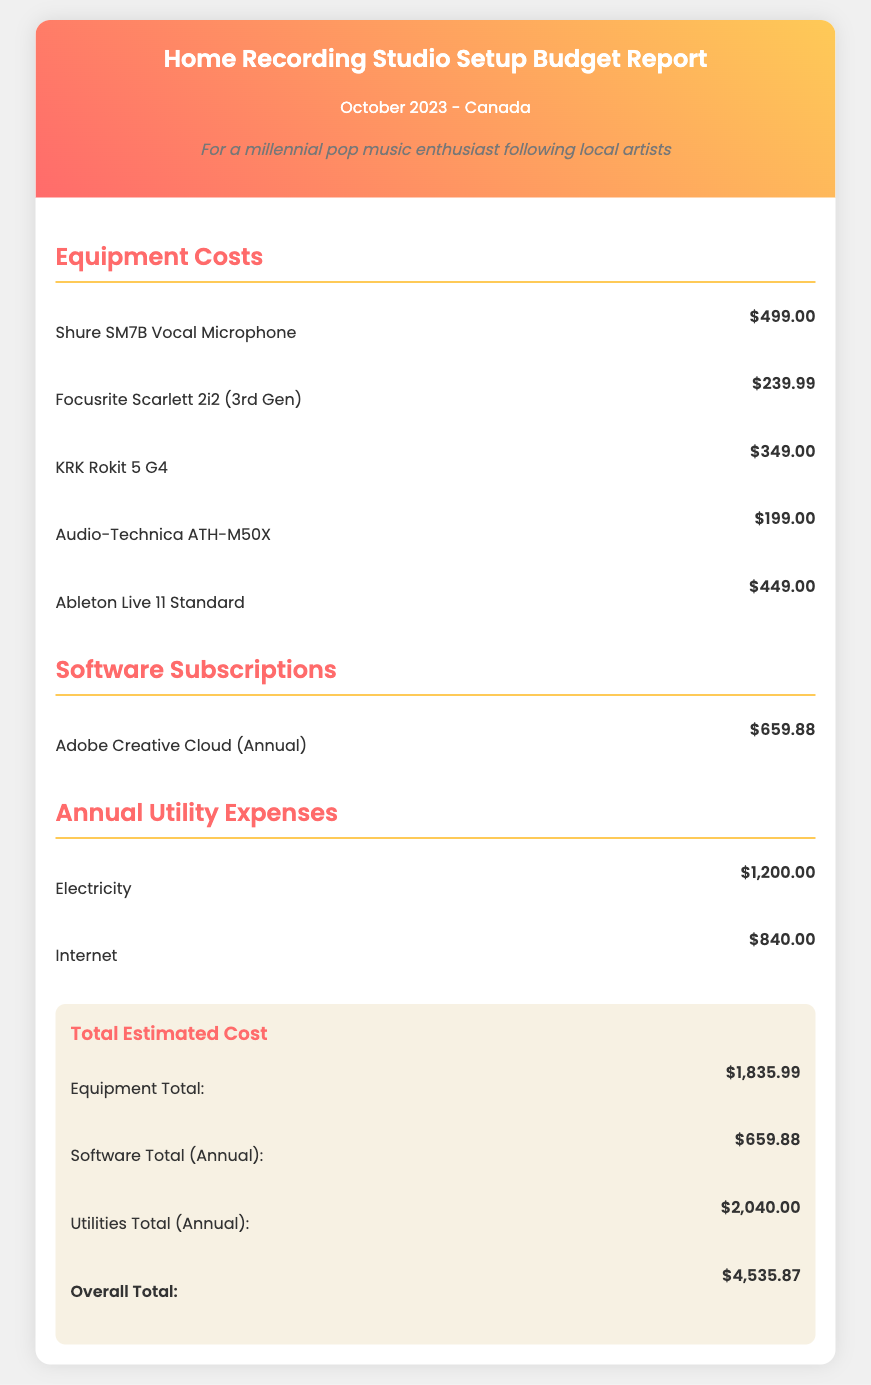What is the total estimated cost for setting up the home recording studio? The total estimated cost is presented in the document as the overall total, which is the sum of all expenses.
Answer: $4,535.87 How much does the Shure SM7B Vocal Microphone cost? The document lists the cost of the Shure SM7B Vocal Microphone as a specific item under equipment costs.
Answer: $499.00 What is the annual cost for internet service? The document specifies the cost of internet service under annual utility expenses.
Answer: $840.00 How much is the Ableton Live 11 Standard? The cost of Ableton Live 11 Standard is mentioned as part of the equipment costs in the document.
Answer: $449.00 What is the total cost for utilities? The total cost for utilities is the sum of electricity and internet, which is presented in the document as part of the utility expenses.
Answer: $2,040.00 What is the combined cost of all equipment items? The document summarizes the total cost of all equipment items listed in the budget report.
Answer: $1,835.99 How much is the annual subscription for Adobe Creative Cloud? The document provides the annual subscription cost for Adobe Creative Cloud in the software subscriptions section.
Answer: $659.88 Which equipment costs more than $300? The document lists several equipment items, and we need to identify which ones fall above that price point.
Answer: Shure SM7B Vocal Microphone, KRK Rokit 5 G4, Ableton Live 11 Standard What date is the budget report created? The document indicates the specific date of creation for the budget report in the header section.
Answer: October 2023 